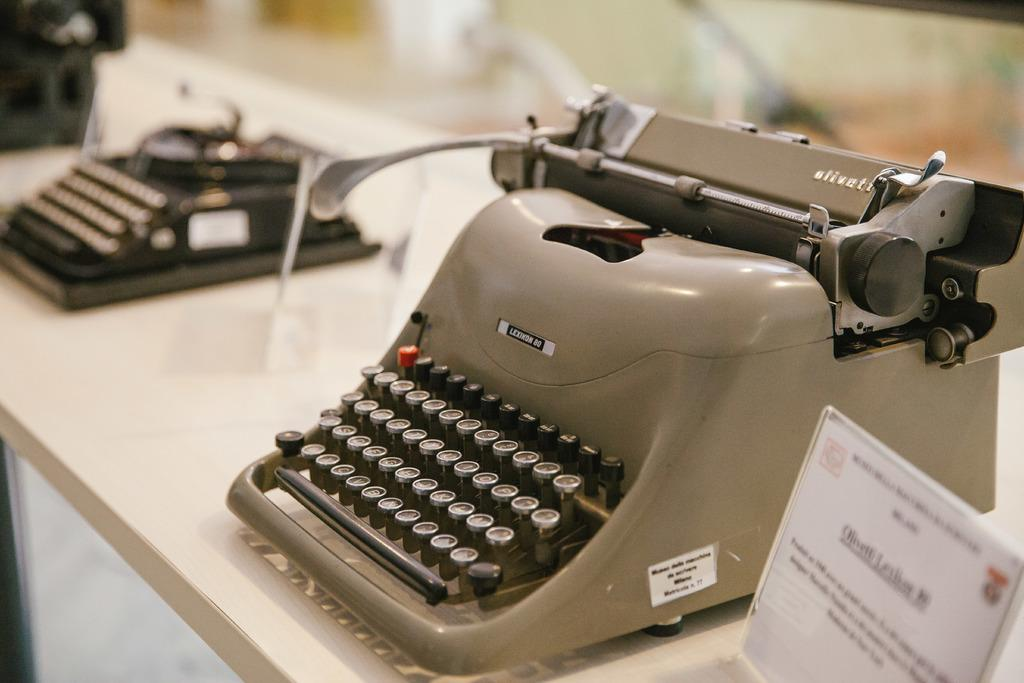Provide a one-sentence caption for the provided image. An antique Olivett typewriter, model Lexikon 80 is sitting on a table. 